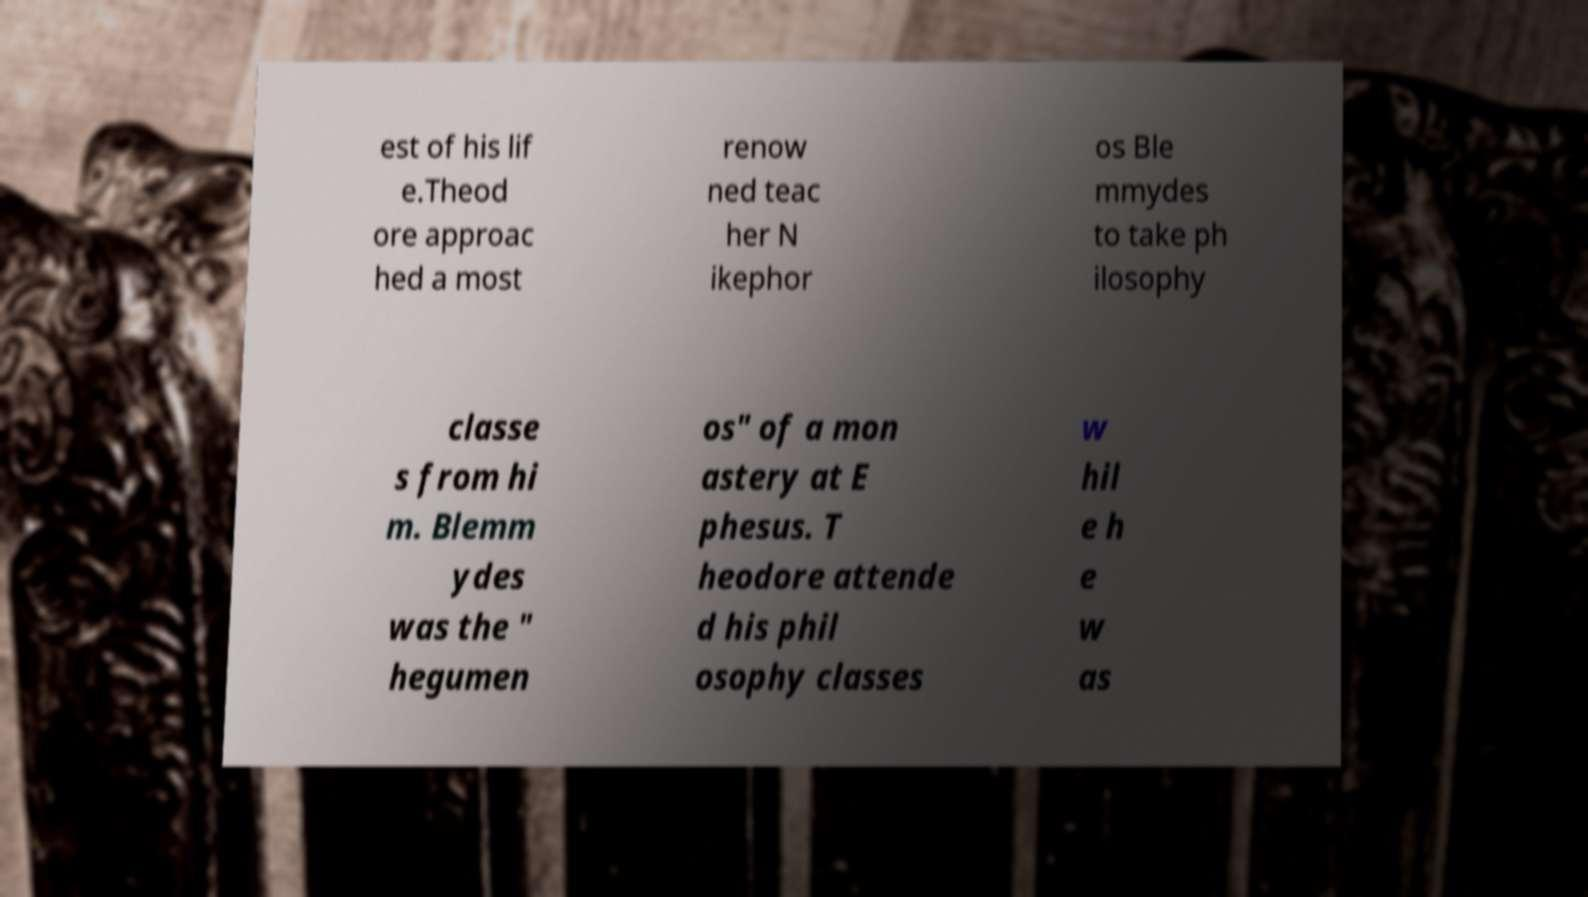What messages or text are displayed in this image? I need them in a readable, typed format. est of his lif e.Theod ore approac hed a most renow ned teac her N ikephor os Ble mmydes to take ph ilosophy classe s from hi m. Blemm ydes was the " hegumen os" of a mon astery at E phesus. T heodore attende d his phil osophy classes w hil e h e w as 